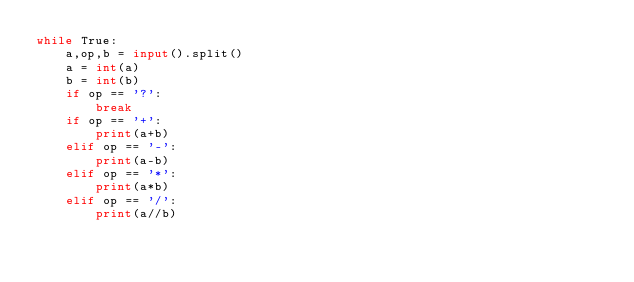<code> <loc_0><loc_0><loc_500><loc_500><_Python_>while True:
    a,op,b = input().split()
    a = int(a)
    b = int(b)
    if op == '?':
        break
    if op == '+':
        print(a+b)
    elif op == '-':
        print(a-b)
    elif op == '*':
        print(a*b)
    elif op == '/':
        print(a//b)
</code> 